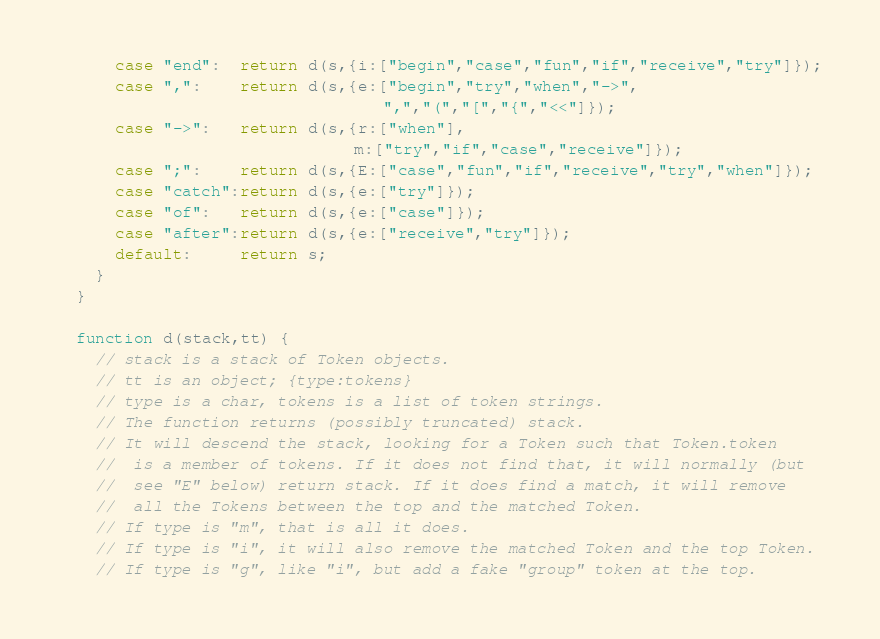Convert code to text. <code><loc_0><loc_0><loc_500><loc_500><_JavaScript_>      case "end":  return d(s,{i:["begin","case","fun","if","receive","try"]});
      case ",":    return d(s,{e:["begin","try","when","->",
                                  ",","(","[","{","<<"]});
      case "->":   return d(s,{r:["when"],
                               m:["try","if","case","receive"]});
      case ";":    return d(s,{E:["case","fun","if","receive","try","when"]});
      case "catch":return d(s,{e:["try"]});
      case "of":   return d(s,{e:["case"]});
      case "after":return d(s,{e:["receive","try"]});
      default:     return s;
    }
  }

  function d(stack,tt) {
    // stack is a stack of Token objects.
    // tt is an object; {type:tokens}
    // type is a char, tokens is a list of token strings.
    // The function returns (possibly truncated) stack.
    // It will descend the stack, looking for a Token such that Token.token
    //  is a member of tokens. If it does not find that, it will normally (but
    //  see "E" below) return stack. If it does find a match, it will remove
    //  all the Tokens between the top and the matched Token.
    // If type is "m", that is all it does.
    // If type is "i", it will also remove the matched Token and the top Token.
    // If type is "g", like "i", but add a fake "group" token at the top.</code> 